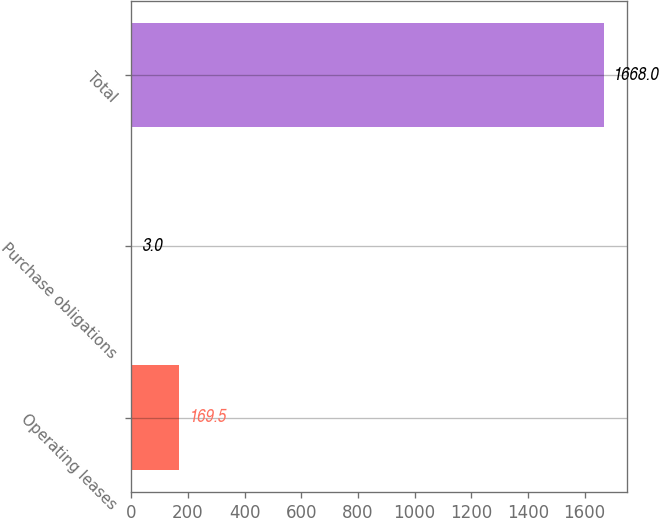<chart> <loc_0><loc_0><loc_500><loc_500><bar_chart><fcel>Operating leases<fcel>Purchase obligations<fcel>Total<nl><fcel>169.5<fcel>3<fcel>1668<nl></chart> 